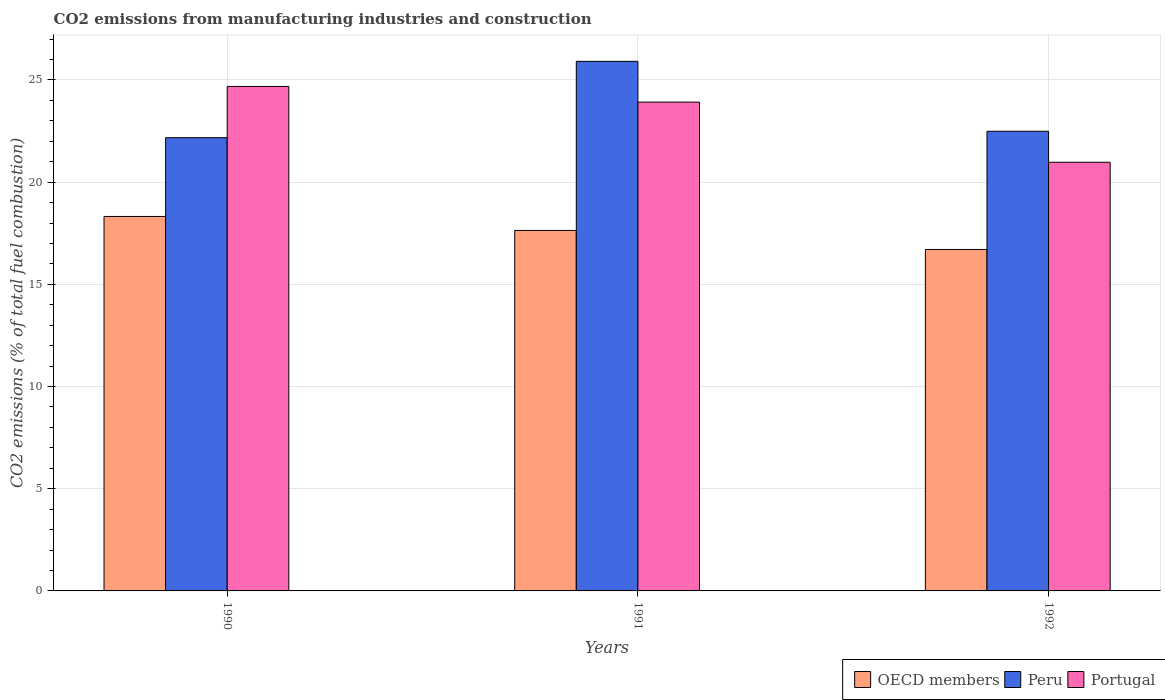Are the number of bars on each tick of the X-axis equal?
Your answer should be very brief. Yes. In how many cases, is the number of bars for a given year not equal to the number of legend labels?
Provide a short and direct response. 0. What is the amount of CO2 emitted in Peru in 1992?
Ensure brevity in your answer.  22.49. Across all years, what is the maximum amount of CO2 emitted in OECD members?
Your answer should be compact. 18.32. Across all years, what is the minimum amount of CO2 emitted in Peru?
Offer a terse response. 22.18. What is the total amount of CO2 emitted in OECD members in the graph?
Keep it short and to the point. 52.66. What is the difference between the amount of CO2 emitted in Portugal in 1990 and that in 1992?
Your answer should be compact. 3.71. What is the difference between the amount of CO2 emitted in OECD members in 1992 and the amount of CO2 emitted in Portugal in 1991?
Offer a terse response. -7.21. What is the average amount of CO2 emitted in Portugal per year?
Keep it short and to the point. 23.19. In the year 1990, what is the difference between the amount of CO2 emitted in OECD members and amount of CO2 emitted in Portugal?
Your response must be concise. -6.36. What is the ratio of the amount of CO2 emitted in Peru in 1990 to that in 1992?
Your answer should be compact. 0.99. Is the amount of CO2 emitted in Portugal in 1991 less than that in 1992?
Your answer should be compact. No. What is the difference between the highest and the second highest amount of CO2 emitted in Portugal?
Your answer should be compact. 0.77. What is the difference between the highest and the lowest amount of CO2 emitted in OECD members?
Provide a short and direct response. 1.61. In how many years, is the amount of CO2 emitted in Peru greater than the average amount of CO2 emitted in Peru taken over all years?
Make the answer very short. 1. Is the sum of the amount of CO2 emitted in Peru in 1991 and 1992 greater than the maximum amount of CO2 emitted in Portugal across all years?
Provide a short and direct response. Yes. What does the 3rd bar from the left in 1992 represents?
Keep it short and to the point. Portugal. What does the 1st bar from the right in 1990 represents?
Your answer should be compact. Portugal. Is it the case that in every year, the sum of the amount of CO2 emitted in Portugal and amount of CO2 emitted in OECD members is greater than the amount of CO2 emitted in Peru?
Ensure brevity in your answer.  Yes. Are all the bars in the graph horizontal?
Make the answer very short. No. Are the values on the major ticks of Y-axis written in scientific E-notation?
Provide a short and direct response. No. Does the graph contain any zero values?
Your answer should be compact. No. Does the graph contain grids?
Keep it short and to the point. Yes. How many legend labels are there?
Offer a very short reply. 3. How are the legend labels stacked?
Ensure brevity in your answer.  Horizontal. What is the title of the graph?
Keep it short and to the point. CO2 emissions from manufacturing industries and construction. Does "Vietnam" appear as one of the legend labels in the graph?
Provide a succinct answer. No. What is the label or title of the Y-axis?
Your response must be concise. CO2 emissions (% of total fuel combustion). What is the CO2 emissions (% of total fuel combustion) in OECD members in 1990?
Ensure brevity in your answer.  18.32. What is the CO2 emissions (% of total fuel combustion) in Peru in 1990?
Offer a very short reply. 22.18. What is the CO2 emissions (% of total fuel combustion) in Portugal in 1990?
Your response must be concise. 24.68. What is the CO2 emissions (% of total fuel combustion) in OECD members in 1991?
Make the answer very short. 17.64. What is the CO2 emissions (% of total fuel combustion) in Peru in 1991?
Ensure brevity in your answer.  25.91. What is the CO2 emissions (% of total fuel combustion) in Portugal in 1991?
Ensure brevity in your answer.  23.91. What is the CO2 emissions (% of total fuel combustion) of OECD members in 1992?
Keep it short and to the point. 16.71. What is the CO2 emissions (% of total fuel combustion) of Peru in 1992?
Offer a very short reply. 22.49. What is the CO2 emissions (% of total fuel combustion) of Portugal in 1992?
Make the answer very short. 20.97. Across all years, what is the maximum CO2 emissions (% of total fuel combustion) of OECD members?
Give a very brief answer. 18.32. Across all years, what is the maximum CO2 emissions (% of total fuel combustion) in Peru?
Give a very brief answer. 25.91. Across all years, what is the maximum CO2 emissions (% of total fuel combustion) in Portugal?
Ensure brevity in your answer.  24.68. Across all years, what is the minimum CO2 emissions (% of total fuel combustion) of OECD members?
Your answer should be compact. 16.71. Across all years, what is the minimum CO2 emissions (% of total fuel combustion) of Peru?
Your response must be concise. 22.18. Across all years, what is the minimum CO2 emissions (% of total fuel combustion) in Portugal?
Your answer should be compact. 20.97. What is the total CO2 emissions (% of total fuel combustion) of OECD members in the graph?
Keep it short and to the point. 52.66. What is the total CO2 emissions (% of total fuel combustion) in Peru in the graph?
Your answer should be compact. 70.58. What is the total CO2 emissions (% of total fuel combustion) in Portugal in the graph?
Keep it short and to the point. 69.57. What is the difference between the CO2 emissions (% of total fuel combustion) in OECD members in 1990 and that in 1991?
Your response must be concise. 0.68. What is the difference between the CO2 emissions (% of total fuel combustion) of Peru in 1990 and that in 1991?
Ensure brevity in your answer.  -3.73. What is the difference between the CO2 emissions (% of total fuel combustion) of Portugal in 1990 and that in 1991?
Give a very brief answer. 0.77. What is the difference between the CO2 emissions (% of total fuel combustion) in OECD members in 1990 and that in 1992?
Offer a very short reply. 1.61. What is the difference between the CO2 emissions (% of total fuel combustion) of Peru in 1990 and that in 1992?
Your answer should be very brief. -0.32. What is the difference between the CO2 emissions (% of total fuel combustion) of Portugal in 1990 and that in 1992?
Your answer should be compact. 3.71. What is the difference between the CO2 emissions (% of total fuel combustion) of OECD members in 1991 and that in 1992?
Offer a terse response. 0.93. What is the difference between the CO2 emissions (% of total fuel combustion) of Peru in 1991 and that in 1992?
Your answer should be compact. 3.42. What is the difference between the CO2 emissions (% of total fuel combustion) in Portugal in 1991 and that in 1992?
Keep it short and to the point. 2.94. What is the difference between the CO2 emissions (% of total fuel combustion) in OECD members in 1990 and the CO2 emissions (% of total fuel combustion) in Peru in 1991?
Make the answer very short. -7.59. What is the difference between the CO2 emissions (% of total fuel combustion) of OECD members in 1990 and the CO2 emissions (% of total fuel combustion) of Portugal in 1991?
Your response must be concise. -5.59. What is the difference between the CO2 emissions (% of total fuel combustion) of Peru in 1990 and the CO2 emissions (% of total fuel combustion) of Portugal in 1991?
Offer a very short reply. -1.74. What is the difference between the CO2 emissions (% of total fuel combustion) in OECD members in 1990 and the CO2 emissions (% of total fuel combustion) in Peru in 1992?
Your response must be concise. -4.17. What is the difference between the CO2 emissions (% of total fuel combustion) in OECD members in 1990 and the CO2 emissions (% of total fuel combustion) in Portugal in 1992?
Provide a short and direct response. -2.65. What is the difference between the CO2 emissions (% of total fuel combustion) in Peru in 1990 and the CO2 emissions (% of total fuel combustion) in Portugal in 1992?
Make the answer very short. 1.2. What is the difference between the CO2 emissions (% of total fuel combustion) of OECD members in 1991 and the CO2 emissions (% of total fuel combustion) of Peru in 1992?
Keep it short and to the point. -4.85. What is the difference between the CO2 emissions (% of total fuel combustion) of OECD members in 1991 and the CO2 emissions (% of total fuel combustion) of Portugal in 1992?
Offer a very short reply. -3.34. What is the difference between the CO2 emissions (% of total fuel combustion) of Peru in 1991 and the CO2 emissions (% of total fuel combustion) of Portugal in 1992?
Your answer should be compact. 4.94. What is the average CO2 emissions (% of total fuel combustion) in OECD members per year?
Provide a short and direct response. 17.55. What is the average CO2 emissions (% of total fuel combustion) in Peru per year?
Ensure brevity in your answer.  23.53. What is the average CO2 emissions (% of total fuel combustion) in Portugal per year?
Offer a very short reply. 23.19. In the year 1990, what is the difference between the CO2 emissions (% of total fuel combustion) of OECD members and CO2 emissions (% of total fuel combustion) of Peru?
Give a very brief answer. -3.86. In the year 1990, what is the difference between the CO2 emissions (% of total fuel combustion) of OECD members and CO2 emissions (% of total fuel combustion) of Portugal?
Give a very brief answer. -6.36. In the year 1990, what is the difference between the CO2 emissions (% of total fuel combustion) of Peru and CO2 emissions (% of total fuel combustion) of Portugal?
Offer a very short reply. -2.51. In the year 1991, what is the difference between the CO2 emissions (% of total fuel combustion) of OECD members and CO2 emissions (% of total fuel combustion) of Peru?
Ensure brevity in your answer.  -8.27. In the year 1991, what is the difference between the CO2 emissions (% of total fuel combustion) of OECD members and CO2 emissions (% of total fuel combustion) of Portugal?
Make the answer very short. -6.28. In the year 1991, what is the difference between the CO2 emissions (% of total fuel combustion) of Peru and CO2 emissions (% of total fuel combustion) of Portugal?
Your response must be concise. 2. In the year 1992, what is the difference between the CO2 emissions (% of total fuel combustion) of OECD members and CO2 emissions (% of total fuel combustion) of Peru?
Make the answer very short. -5.79. In the year 1992, what is the difference between the CO2 emissions (% of total fuel combustion) of OECD members and CO2 emissions (% of total fuel combustion) of Portugal?
Ensure brevity in your answer.  -4.27. In the year 1992, what is the difference between the CO2 emissions (% of total fuel combustion) in Peru and CO2 emissions (% of total fuel combustion) in Portugal?
Your response must be concise. 1.52. What is the ratio of the CO2 emissions (% of total fuel combustion) in OECD members in 1990 to that in 1991?
Offer a very short reply. 1.04. What is the ratio of the CO2 emissions (% of total fuel combustion) in Peru in 1990 to that in 1991?
Offer a very short reply. 0.86. What is the ratio of the CO2 emissions (% of total fuel combustion) of Portugal in 1990 to that in 1991?
Your answer should be compact. 1.03. What is the ratio of the CO2 emissions (% of total fuel combustion) in OECD members in 1990 to that in 1992?
Give a very brief answer. 1.1. What is the ratio of the CO2 emissions (% of total fuel combustion) of Portugal in 1990 to that in 1992?
Your answer should be compact. 1.18. What is the ratio of the CO2 emissions (% of total fuel combustion) of OECD members in 1991 to that in 1992?
Give a very brief answer. 1.06. What is the ratio of the CO2 emissions (% of total fuel combustion) of Peru in 1991 to that in 1992?
Offer a very short reply. 1.15. What is the ratio of the CO2 emissions (% of total fuel combustion) of Portugal in 1991 to that in 1992?
Your response must be concise. 1.14. What is the difference between the highest and the second highest CO2 emissions (% of total fuel combustion) of OECD members?
Provide a succinct answer. 0.68. What is the difference between the highest and the second highest CO2 emissions (% of total fuel combustion) of Peru?
Your answer should be very brief. 3.42. What is the difference between the highest and the second highest CO2 emissions (% of total fuel combustion) in Portugal?
Your answer should be compact. 0.77. What is the difference between the highest and the lowest CO2 emissions (% of total fuel combustion) in OECD members?
Offer a very short reply. 1.61. What is the difference between the highest and the lowest CO2 emissions (% of total fuel combustion) of Peru?
Make the answer very short. 3.73. What is the difference between the highest and the lowest CO2 emissions (% of total fuel combustion) in Portugal?
Offer a very short reply. 3.71. 